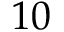<formula> <loc_0><loc_0><loc_500><loc_500>1 0</formula> 